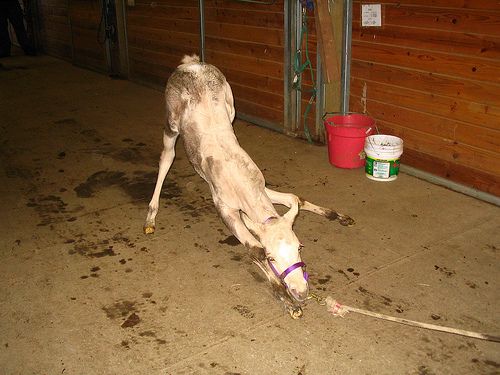<image>
Is the bucket behind the animal? No. The bucket is not behind the animal. From this viewpoint, the bucket appears to be positioned elsewhere in the scene. 